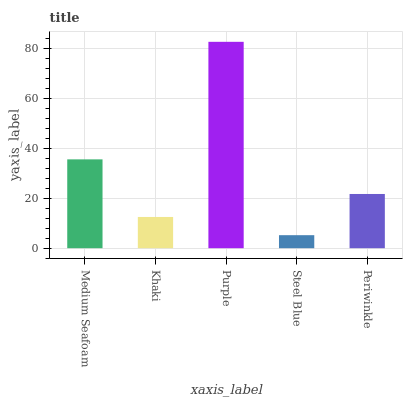Is Steel Blue the minimum?
Answer yes or no. Yes. Is Purple the maximum?
Answer yes or no. Yes. Is Khaki the minimum?
Answer yes or no. No. Is Khaki the maximum?
Answer yes or no. No. Is Medium Seafoam greater than Khaki?
Answer yes or no. Yes. Is Khaki less than Medium Seafoam?
Answer yes or no. Yes. Is Khaki greater than Medium Seafoam?
Answer yes or no. No. Is Medium Seafoam less than Khaki?
Answer yes or no. No. Is Periwinkle the high median?
Answer yes or no. Yes. Is Periwinkle the low median?
Answer yes or no. Yes. Is Steel Blue the high median?
Answer yes or no. No. Is Medium Seafoam the low median?
Answer yes or no. No. 